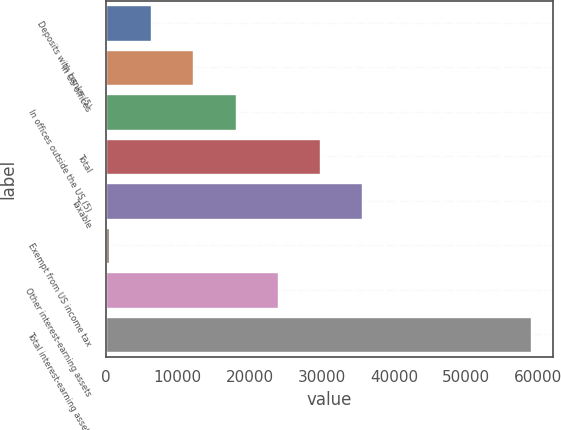<chart> <loc_0><loc_0><loc_500><loc_500><bar_chart><fcel>Deposits with banks (5)<fcel>In US offices<fcel>In offices outside the US (5)<fcel>Total<fcel>Taxable<fcel>Exempt from US income tax<fcel>Other interest-earning assets<fcel>Total interest-earning assets<nl><fcel>6302.7<fcel>12162.4<fcel>18022.1<fcel>29741.5<fcel>35601.2<fcel>443<fcel>23881.8<fcel>59040<nl></chart> 